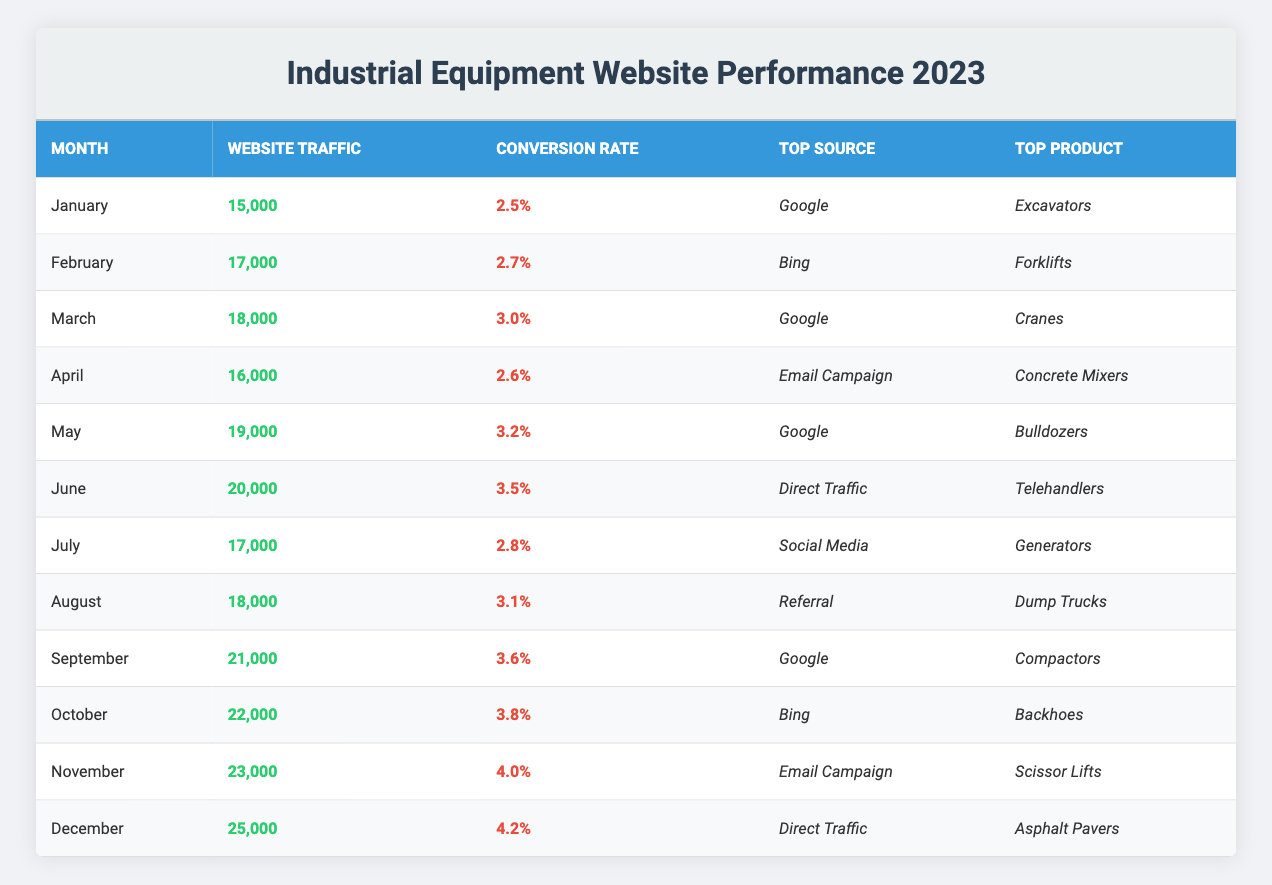What was the website traffic in December? The table shows that the website traffic in December is listed under the corresponding column, which indicates a value of 25,000.
Answer: 25,000 What is the top product sold in May? According to the table, May's top product is mentioned, and it states "Bulldozers" is the top product for that month.
Answer: Bulldozers Which month had the highest conversion rate? The conversion rates for each month are compared in the table, and upon review, November shows the highest value at 4.0%.
Answer: November Did the conversion rate ever drop below 2.5% in 2023? By analyzing the conversion rates listed in the table, we see the lowest conversion rate is 2.5% in January, which means it did not drop below this value throughout the year.
Answer: No What was the average website traffic from January to March? The website traffic values for January (15,000), February (17,000), and March (18,000) are summed up, yielding 15,000 + 17,000 + 18,000 = 50,000. Then, we divide by the number of months (3) to find the average: 50,000 / 3 = 16,666.67.
Answer: 16,667 How much did website traffic increase from April to June? The traffic for April is 16,000, and for June, it is 20,000. To find the increase, we subtract: 20,000 - 16,000 = 4,000.
Answer: 4,000 Which source generated the most traffic in September? The table indicates that Google was the top source in September, which is directly referenced under the top source column for that month.
Answer: Google Which month experienced a decrease in website traffic compared to the previous month? By reviewing the traffic values, July (17,000) is lower than June (20,000), indicating a drop. Thus, July had decreased traffic compared to June.
Answer: July What is the total website traffic for the first half of the year (January to June)? The traffic values from January to June are added: 15,000 (Jan) + 17,000 (Feb) + 18,000 (Mar) + 16,000 (Apr) + 19,000 (May) + 20,000 (Jun) = 105,000.
Answer: 105,000 What was the most common top source in the second half of the year? From July to December, Google (September), Bing (October), Email Campaign (November), and Direct Traffic (December) are noted. Reviewing the list, Google was seen twice, making it the most common source.
Answer: Google 